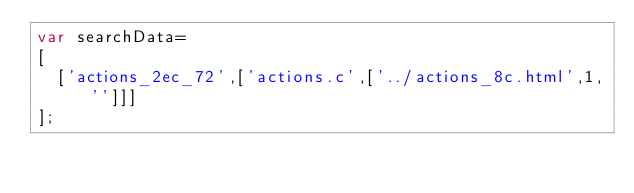Convert code to text. <code><loc_0><loc_0><loc_500><loc_500><_JavaScript_>var searchData=
[
  ['actions_2ec_72',['actions.c',['../actions_8c.html',1,'']]]
];
</code> 